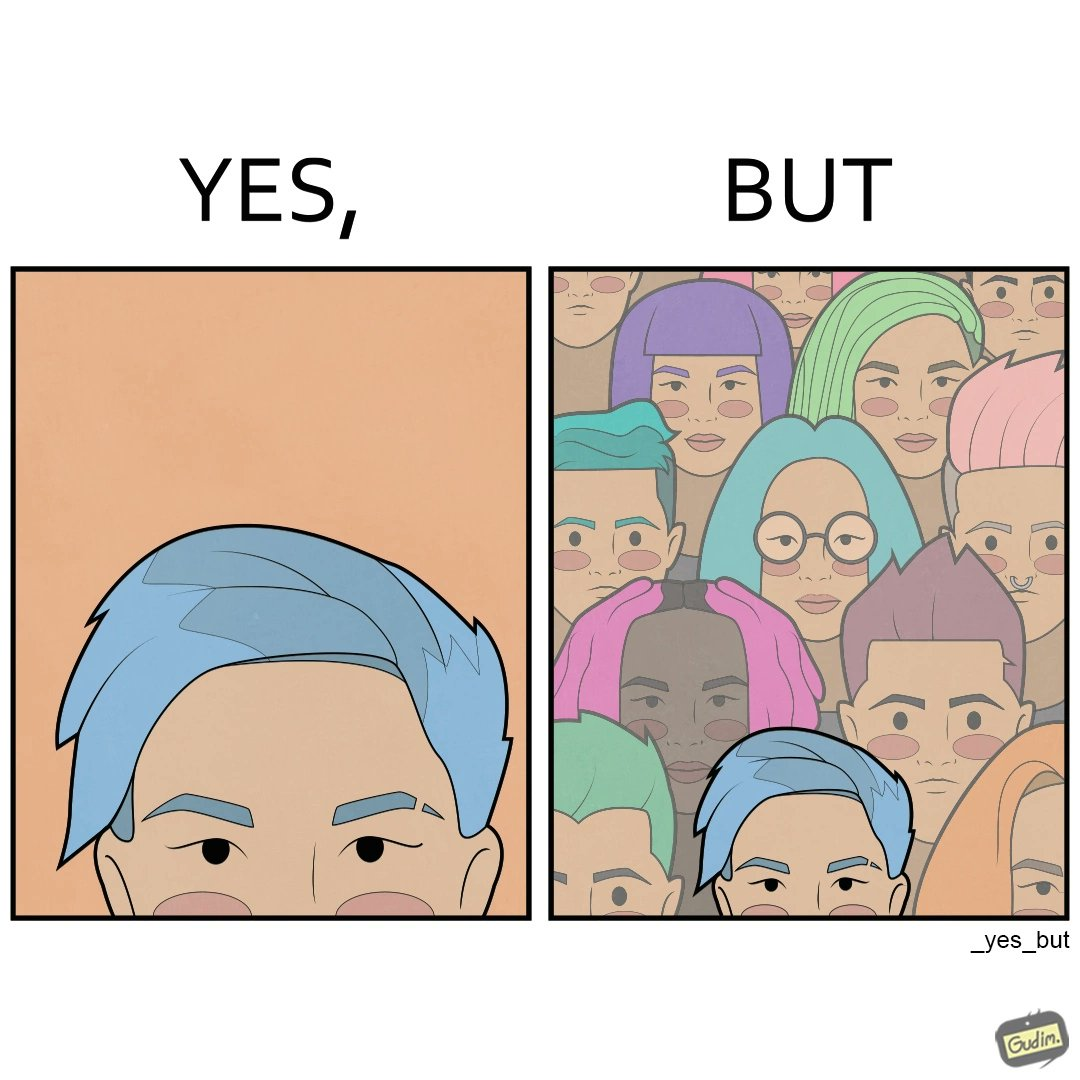Would you classify this image as satirical? Yes, this image is satirical. 